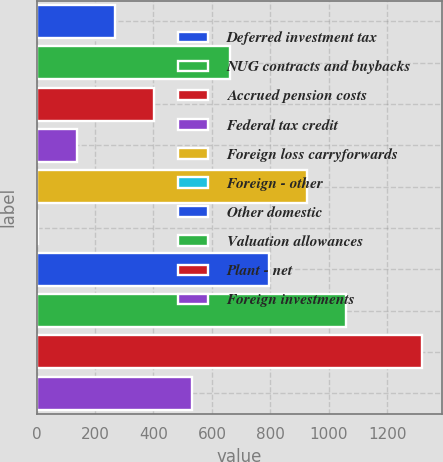Convert chart. <chart><loc_0><loc_0><loc_500><loc_500><bar_chart><fcel>Deferred investment tax<fcel>NUG contracts and buybacks<fcel>Accrued pension costs<fcel>Federal tax credit<fcel>Foreign loss carryforwards<fcel>Foreign - other<fcel>Other domestic<fcel>Valuation allowances<fcel>Plant - net<fcel>Foreign investments<nl><fcel>268.8<fcel>663<fcel>400.2<fcel>137.4<fcel>925.8<fcel>6<fcel>794.4<fcel>1057.2<fcel>1320<fcel>531.6<nl></chart> 